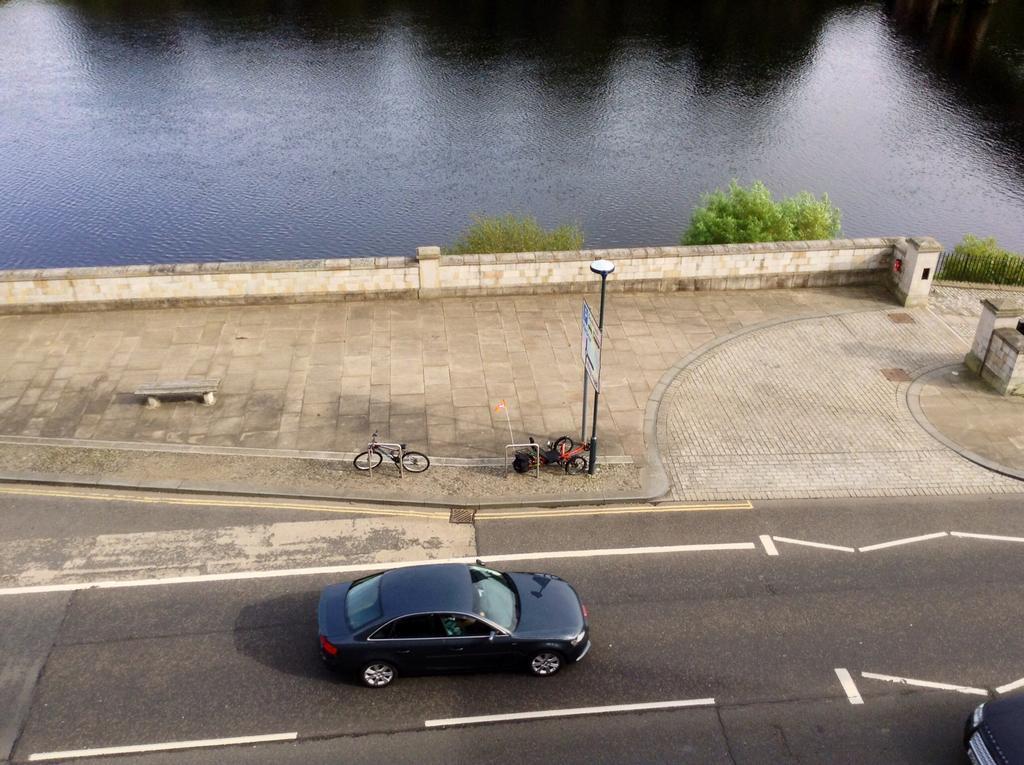In one or two sentences, can you explain what this image depicts? There is a vehicle on the road and on the footpath there is a vehicle and bicycle at the pole and we can also see a bench,hoarding,fence,trees and water. 